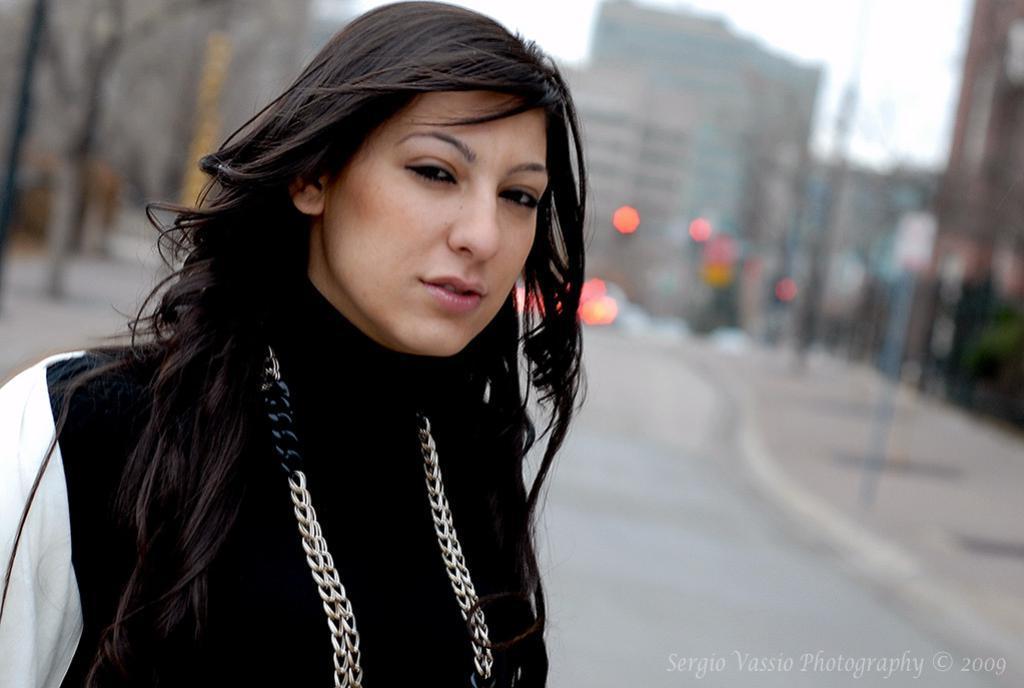Describe this image in one or two sentences. There is a woman standing with the black dress and wearing chain around her neck. She is standing on the road. In the background which is blurred, we can observe some buildings and poles. 